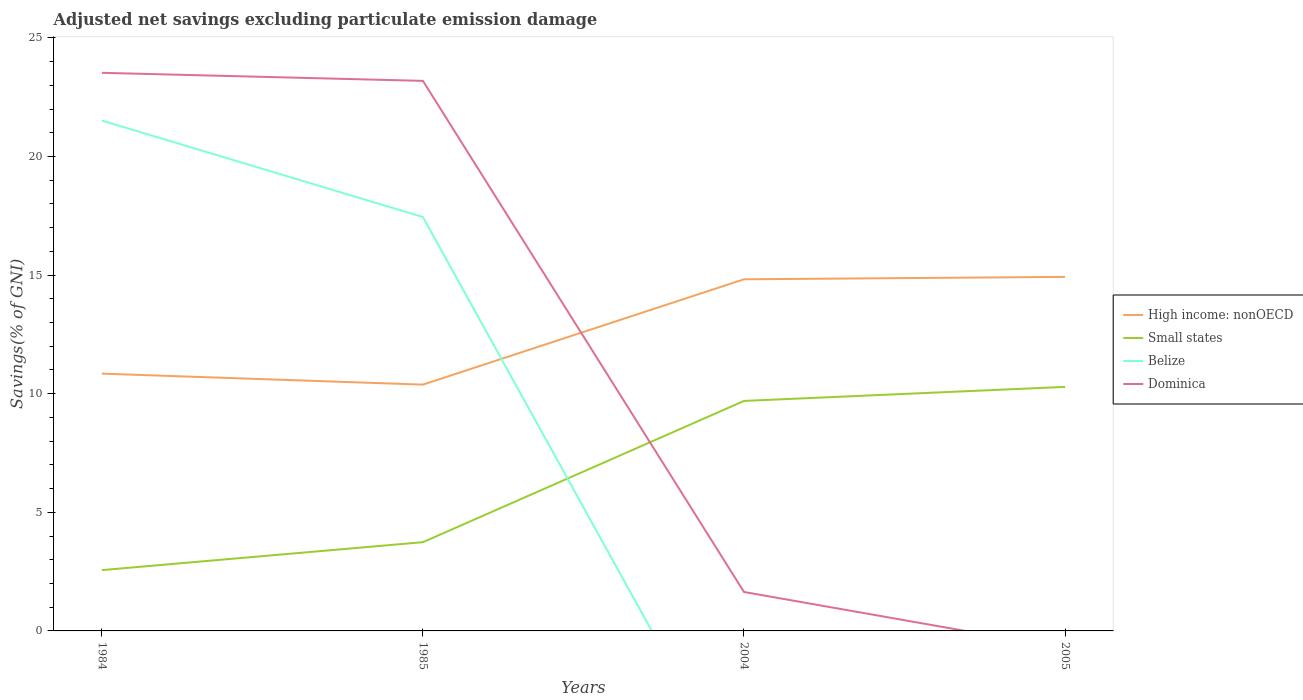How many different coloured lines are there?
Provide a succinct answer. 4. Across all years, what is the maximum adjusted net savings in Belize?
Your answer should be very brief. 0. What is the total adjusted net savings in Small states in the graph?
Ensure brevity in your answer.  -7.72. What is the difference between the highest and the second highest adjusted net savings in Belize?
Your answer should be compact. 21.52. What is the difference between the highest and the lowest adjusted net savings in Belize?
Make the answer very short. 2. How many lines are there?
Keep it short and to the point. 4. Are the values on the major ticks of Y-axis written in scientific E-notation?
Give a very brief answer. No. How many legend labels are there?
Offer a terse response. 4. How are the legend labels stacked?
Give a very brief answer. Vertical. What is the title of the graph?
Keep it short and to the point. Adjusted net savings excluding particulate emission damage. Does "Slovak Republic" appear as one of the legend labels in the graph?
Provide a succinct answer. No. What is the label or title of the X-axis?
Offer a very short reply. Years. What is the label or title of the Y-axis?
Provide a short and direct response. Savings(% of GNI). What is the Savings(% of GNI) in High income: nonOECD in 1984?
Your answer should be compact. 10.85. What is the Savings(% of GNI) of Small states in 1984?
Your answer should be very brief. 2.56. What is the Savings(% of GNI) in Belize in 1984?
Give a very brief answer. 21.52. What is the Savings(% of GNI) of Dominica in 1984?
Give a very brief answer. 23.53. What is the Savings(% of GNI) in High income: nonOECD in 1985?
Your answer should be compact. 10.38. What is the Savings(% of GNI) in Small states in 1985?
Your answer should be compact. 3.74. What is the Savings(% of GNI) of Belize in 1985?
Make the answer very short. 17.45. What is the Savings(% of GNI) of Dominica in 1985?
Offer a very short reply. 23.19. What is the Savings(% of GNI) of High income: nonOECD in 2004?
Give a very brief answer. 14.82. What is the Savings(% of GNI) in Small states in 2004?
Your answer should be compact. 9.7. What is the Savings(% of GNI) of Belize in 2004?
Keep it short and to the point. 0. What is the Savings(% of GNI) of Dominica in 2004?
Make the answer very short. 1.64. What is the Savings(% of GNI) of High income: nonOECD in 2005?
Your response must be concise. 14.92. What is the Savings(% of GNI) in Small states in 2005?
Offer a very short reply. 10.29. What is the Savings(% of GNI) of Belize in 2005?
Provide a succinct answer. 0. What is the Savings(% of GNI) in Dominica in 2005?
Give a very brief answer. 0. Across all years, what is the maximum Savings(% of GNI) in High income: nonOECD?
Offer a terse response. 14.92. Across all years, what is the maximum Savings(% of GNI) in Small states?
Offer a terse response. 10.29. Across all years, what is the maximum Savings(% of GNI) in Belize?
Your response must be concise. 21.52. Across all years, what is the maximum Savings(% of GNI) in Dominica?
Offer a very short reply. 23.53. Across all years, what is the minimum Savings(% of GNI) in High income: nonOECD?
Give a very brief answer. 10.38. Across all years, what is the minimum Savings(% of GNI) of Small states?
Make the answer very short. 2.56. Across all years, what is the minimum Savings(% of GNI) in Belize?
Give a very brief answer. 0. Across all years, what is the minimum Savings(% of GNI) of Dominica?
Your answer should be very brief. 0. What is the total Savings(% of GNI) in High income: nonOECD in the graph?
Provide a short and direct response. 50.98. What is the total Savings(% of GNI) of Small states in the graph?
Your answer should be compact. 26.29. What is the total Savings(% of GNI) of Belize in the graph?
Offer a very short reply. 38.96. What is the total Savings(% of GNI) in Dominica in the graph?
Your answer should be very brief. 48.36. What is the difference between the Savings(% of GNI) of High income: nonOECD in 1984 and that in 1985?
Provide a short and direct response. 0.46. What is the difference between the Savings(% of GNI) of Small states in 1984 and that in 1985?
Offer a very short reply. -1.18. What is the difference between the Savings(% of GNI) of Belize in 1984 and that in 1985?
Offer a very short reply. 4.07. What is the difference between the Savings(% of GNI) in Dominica in 1984 and that in 1985?
Your answer should be compact. 0.34. What is the difference between the Savings(% of GNI) of High income: nonOECD in 1984 and that in 2004?
Provide a succinct answer. -3.98. What is the difference between the Savings(% of GNI) of Small states in 1984 and that in 2004?
Offer a very short reply. -7.13. What is the difference between the Savings(% of GNI) of Dominica in 1984 and that in 2004?
Keep it short and to the point. 21.89. What is the difference between the Savings(% of GNI) of High income: nonOECD in 1984 and that in 2005?
Your response must be concise. -4.08. What is the difference between the Savings(% of GNI) of Small states in 1984 and that in 2005?
Ensure brevity in your answer.  -7.72. What is the difference between the Savings(% of GNI) in High income: nonOECD in 1985 and that in 2004?
Offer a very short reply. -4.44. What is the difference between the Savings(% of GNI) of Small states in 1985 and that in 2004?
Your answer should be compact. -5.95. What is the difference between the Savings(% of GNI) in Dominica in 1985 and that in 2004?
Offer a terse response. 21.55. What is the difference between the Savings(% of GNI) in High income: nonOECD in 1985 and that in 2005?
Provide a succinct answer. -4.54. What is the difference between the Savings(% of GNI) in Small states in 1985 and that in 2005?
Give a very brief answer. -6.55. What is the difference between the Savings(% of GNI) of High income: nonOECD in 2004 and that in 2005?
Offer a terse response. -0.1. What is the difference between the Savings(% of GNI) of Small states in 2004 and that in 2005?
Make the answer very short. -0.59. What is the difference between the Savings(% of GNI) of High income: nonOECD in 1984 and the Savings(% of GNI) of Small states in 1985?
Your answer should be very brief. 7.11. What is the difference between the Savings(% of GNI) of High income: nonOECD in 1984 and the Savings(% of GNI) of Belize in 1985?
Keep it short and to the point. -6.6. What is the difference between the Savings(% of GNI) of High income: nonOECD in 1984 and the Savings(% of GNI) of Dominica in 1985?
Your answer should be compact. -12.34. What is the difference between the Savings(% of GNI) in Small states in 1984 and the Savings(% of GNI) in Belize in 1985?
Provide a succinct answer. -14.88. What is the difference between the Savings(% of GNI) in Small states in 1984 and the Savings(% of GNI) in Dominica in 1985?
Keep it short and to the point. -20.62. What is the difference between the Savings(% of GNI) in Belize in 1984 and the Savings(% of GNI) in Dominica in 1985?
Keep it short and to the point. -1.67. What is the difference between the Savings(% of GNI) of High income: nonOECD in 1984 and the Savings(% of GNI) of Small states in 2004?
Offer a terse response. 1.15. What is the difference between the Savings(% of GNI) in High income: nonOECD in 1984 and the Savings(% of GNI) in Dominica in 2004?
Keep it short and to the point. 9.2. What is the difference between the Savings(% of GNI) in Small states in 1984 and the Savings(% of GNI) in Dominica in 2004?
Keep it short and to the point. 0.92. What is the difference between the Savings(% of GNI) in Belize in 1984 and the Savings(% of GNI) in Dominica in 2004?
Make the answer very short. 19.87. What is the difference between the Savings(% of GNI) in High income: nonOECD in 1984 and the Savings(% of GNI) in Small states in 2005?
Make the answer very short. 0.56. What is the difference between the Savings(% of GNI) in High income: nonOECD in 1985 and the Savings(% of GNI) in Small states in 2004?
Offer a very short reply. 0.69. What is the difference between the Savings(% of GNI) in High income: nonOECD in 1985 and the Savings(% of GNI) in Dominica in 2004?
Ensure brevity in your answer.  8.74. What is the difference between the Savings(% of GNI) in Small states in 1985 and the Savings(% of GNI) in Dominica in 2004?
Offer a terse response. 2.1. What is the difference between the Savings(% of GNI) of Belize in 1985 and the Savings(% of GNI) of Dominica in 2004?
Your answer should be very brief. 15.81. What is the difference between the Savings(% of GNI) of High income: nonOECD in 1985 and the Savings(% of GNI) of Small states in 2005?
Provide a short and direct response. 0.1. What is the difference between the Savings(% of GNI) of High income: nonOECD in 2004 and the Savings(% of GNI) of Small states in 2005?
Your answer should be very brief. 4.54. What is the average Savings(% of GNI) in High income: nonOECD per year?
Your answer should be very brief. 12.74. What is the average Savings(% of GNI) in Small states per year?
Keep it short and to the point. 6.57. What is the average Savings(% of GNI) of Belize per year?
Your response must be concise. 9.74. What is the average Savings(% of GNI) in Dominica per year?
Offer a terse response. 12.09. In the year 1984, what is the difference between the Savings(% of GNI) of High income: nonOECD and Savings(% of GNI) of Small states?
Give a very brief answer. 8.28. In the year 1984, what is the difference between the Savings(% of GNI) in High income: nonOECD and Savings(% of GNI) in Belize?
Make the answer very short. -10.67. In the year 1984, what is the difference between the Savings(% of GNI) of High income: nonOECD and Savings(% of GNI) of Dominica?
Offer a terse response. -12.68. In the year 1984, what is the difference between the Savings(% of GNI) in Small states and Savings(% of GNI) in Belize?
Provide a succinct answer. -18.95. In the year 1984, what is the difference between the Savings(% of GNI) of Small states and Savings(% of GNI) of Dominica?
Make the answer very short. -20.96. In the year 1984, what is the difference between the Savings(% of GNI) in Belize and Savings(% of GNI) in Dominica?
Provide a succinct answer. -2.01. In the year 1985, what is the difference between the Savings(% of GNI) of High income: nonOECD and Savings(% of GNI) of Small states?
Make the answer very short. 6.64. In the year 1985, what is the difference between the Savings(% of GNI) of High income: nonOECD and Savings(% of GNI) of Belize?
Ensure brevity in your answer.  -7.07. In the year 1985, what is the difference between the Savings(% of GNI) in High income: nonOECD and Savings(% of GNI) in Dominica?
Give a very brief answer. -12.81. In the year 1985, what is the difference between the Savings(% of GNI) in Small states and Savings(% of GNI) in Belize?
Provide a succinct answer. -13.71. In the year 1985, what is the difference between the Savings(% of GNI) of Small states and Savings(% of GNI) of Dominica?
Offer a terse response. -19.45. In the year 1985, what is the difference between the Savings(% of GNI) of Belize and Savings(% of GNI) of Dominica?
Offer a terse response. -5.74. In the year 2004, what is the difference between the Savings(% of GNI) in High income: nonOECD and Savings(% of GNI) in Small states?
Your answer should be compact. 5.13. In the year 2004, what is the difference between the Savings(% of GNI) in High income: nonOECD and Savings(% of GNI) in Dominica?
Provide a short and direct response. 13.18. In the year 2004, what is the difference between the Savings(% of GNI) of Small states and Savings(% of GNI) of Dominica?
Give a very brief answer. 8.05. In the year 2005, what is the difference between the Savings(% of GNI) in High income: nonOECD and Savings(% of GNI) in Small states?
Your response must be concise. 4.64. What is the ratio of the Savings(% of GNI) of High income: nonOECD in 1984 to that in 1985?
Your answer should be compact. 1.04. What is the ratio of the Savings(% of GNI) of Small states in 1984 to that in 1985?
Offer a very short reply. 0.69. What is the ratio of the Savings(% of GNI) of Belize in 1984 to that in 1985?
Ensure brevity in your answer.  1.23. What is the ratio of the Savings(% of GNI) of Dominica in 1984 to that in 1985?
Provide a succinct answer. 1.01. What is the ratio of the Savings(% of GNI) of High income: nonOECD in 1984 to that in 2004?
Ensure brevity in your answer.  0.73. What is the ratio of the Savings(% of GNI) of Small states in 1984 to that in 2004?
Make the answer very short. 0.26. What is the ratio of the Savings(% of GNI) of Dominica in 1984 to that in 2004?
Offer a very short reply. 14.33. What is the ratio of the Savings(% of GNI) of High income: nonOECD in 1984 to that in 2005?
Provide a short and direct response. 0.73. What is the ratio of the Savings(% of GNI) of Small states in 1984 to that in 2005?
Give a very brief answer. 0.25. What is the ratio of the Savings(% of GNI) of High income: nonOECD in 1985 to that in 2004?
Provide a short and direct response. 0.7. What is the ratio of the Savings(% of GNI) in Small states in 1985 to that in 2004?
Ensure brevity in your answer.  0.39. What is the ratio of the Savings(% of GNI) in Dominica in 1985 to that in 2004?
Provide a short and direct response. 14.12. What is the ratio of the Savings(% of GNI) in High income: nonOECD in 1985 to that in 2005?
Offer a very short reply. 0.7. What is the ratio of the Savings(% of GNI) in Small states in 1985 to that in 2005?
Offer a terse response. 0.36. What is the ratio of the Savings(% of GNI) of Small states in 2004 to that in 2005?
Keep it short and to the point. 0.94. What is the difference between the highest and the second highest Savings(% of GNI) in High income: nonOECD?
Make the answer very short. 0.1. What is the difference between the highest and the second highest Savings(% of GNI) in Small states?
Ensure brevity in your answer.  0.59. What is the difference between the highest and the second highest Savings(% of GNI) of Dominica?
Your answer should be very brief. 0.34. What is the difference between the highest and the lowest Savings(% of GNI) in High income: nonOECD?
Provide a short and direct response. 4.54. What is the difference between the highest and the lowest Savings(% of GNI) of Small states?
Offer a very short reply. 7.72. What is the difference between the highest and the lowest Savings(% of GNI) in Belize?
Provide a short and direct response. 21.52. What is the difference between the highest and the lowest Savings(% of GNI) in Dominica?
Your answer should be very brief. 23.53. 